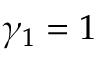Convert formula to latex. <formula><loc_0><loc_0><loc_500><loc_500>\gamma _ { 1 } = 1</formula> 